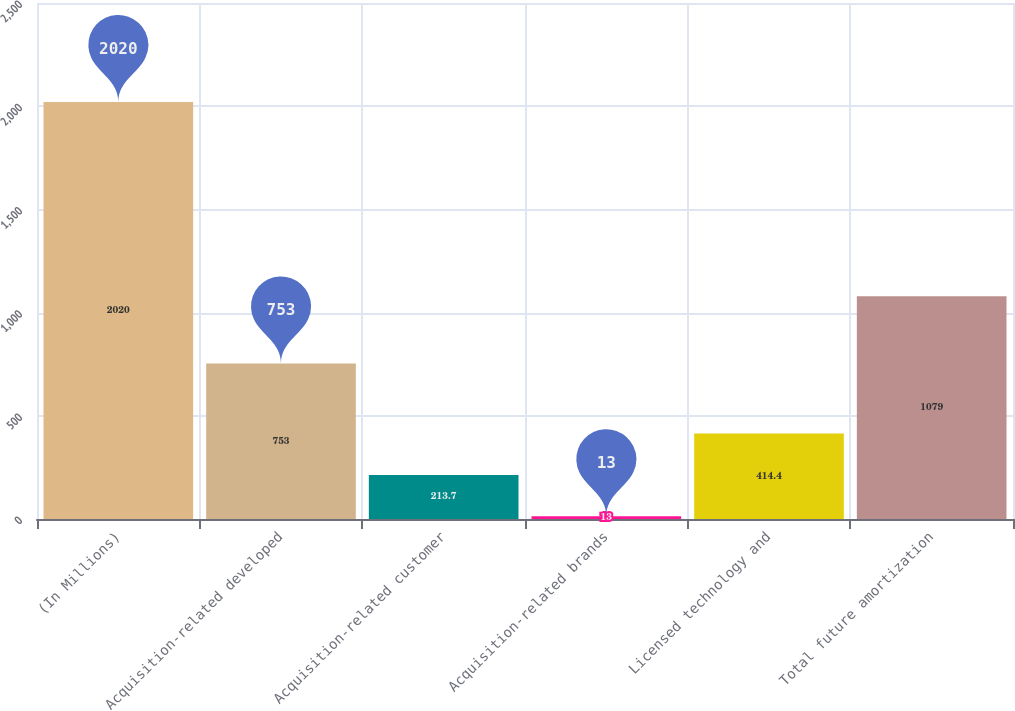<chart> <loc_0><loc_0><loc_500><loc_500><bar_chart><fcel>(In Millions)<fcel>Acquisition-related developed<fcel>Acquisition-related customer<fcel>Acquisition-related brands<fcel>Licensed technology and<fcel>Total future amortization<nl><fcel>2020<fcel>753<fcel>213.7<fcel>13<fcel>414.4<fcel>1079<nl></chart> 